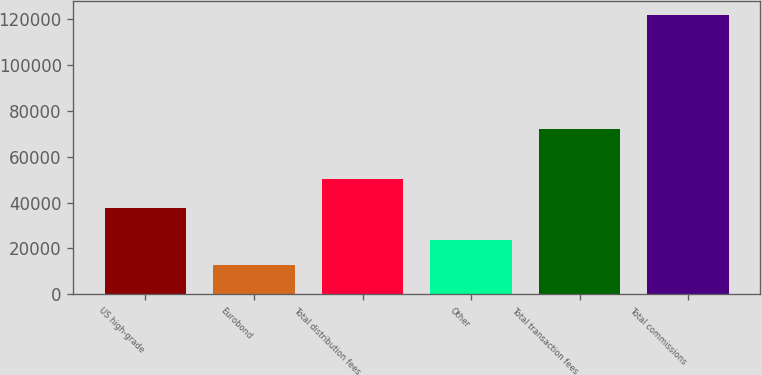Convert chart to OTSL. <chart><loc_0><loc_0><loc_500><loc_500><bar_chart><fcel>US high-grade<fcel>Eurobond<fcel>Total distribution fees<fcel>Other<fcel>Total transaction fees<fcel>Total commissions<nl><fcel>37467<fcel>12693<fcel>50160<fcel>23641.7<fcel>72020<fcel>122180<nl></chart> 